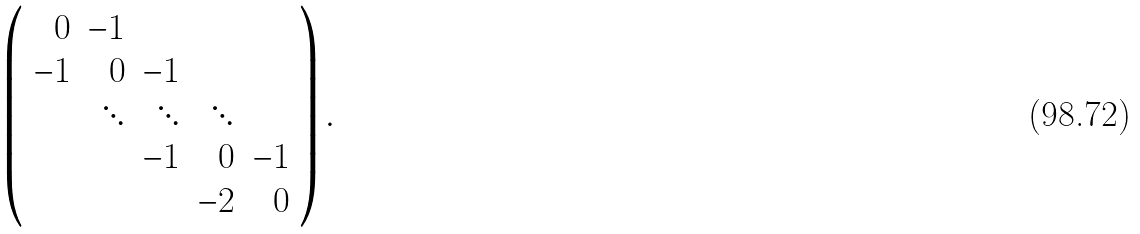<formula> <loc_0><loc_0><loc_500><loc_500>\left ( \begin{array} { r r r r r } 0 & - 1 & & & \\ - 1 & 0 & - 1 & & \\ & \ddots & \ddots & \ddots & \\ & & - 1 & 0 & - 1 \\ & & & - 2 & 0 \end{array} \right ) .</formula> 